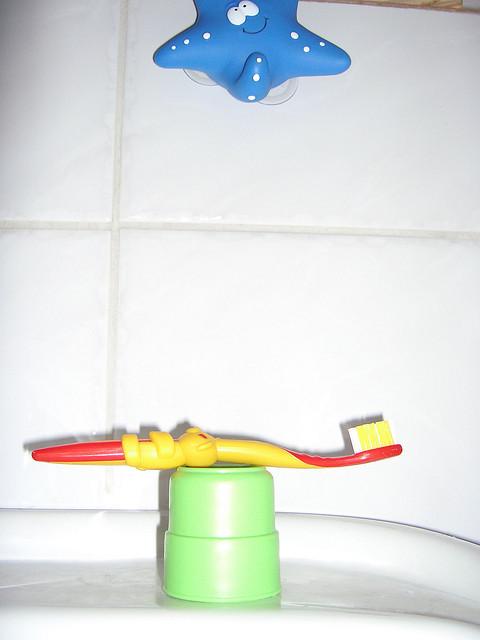What is on top of the cup?
Quick response, please. Toothbrush. What color is the wall?
Give a very brief answer. White. Is that an extended reach toothbrush?
Short answer required. No. 